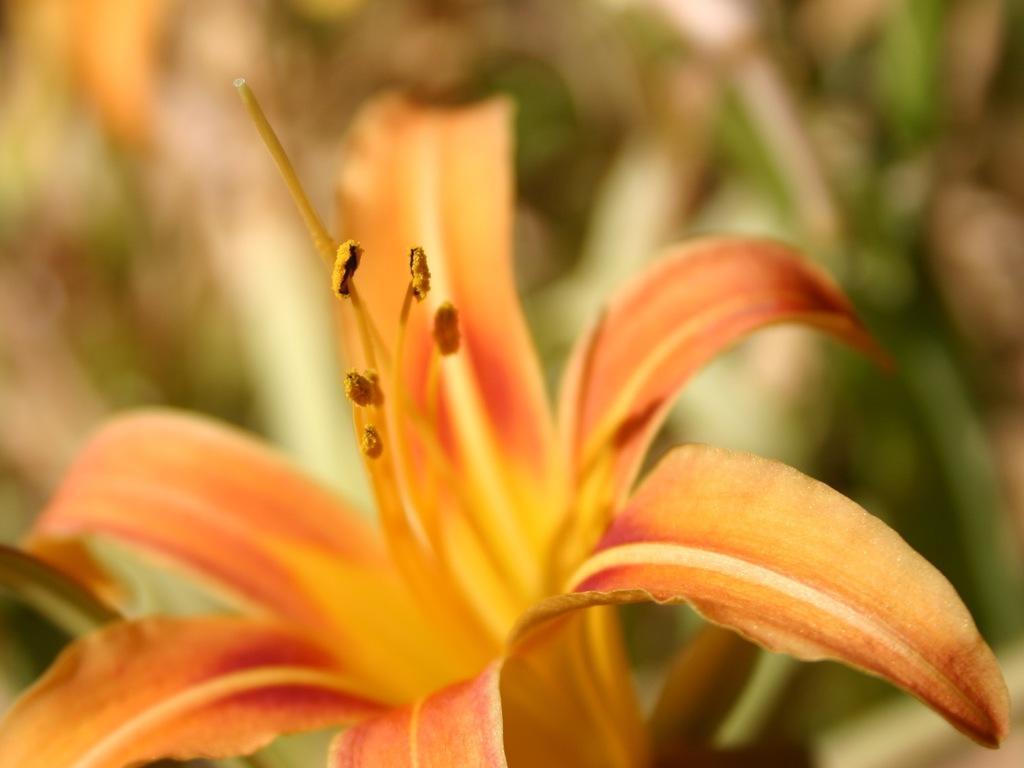In one or two sentences, can you explain what this image depicts? In this picture there is a orange flower on the plant. On the left we can see the leaves. 